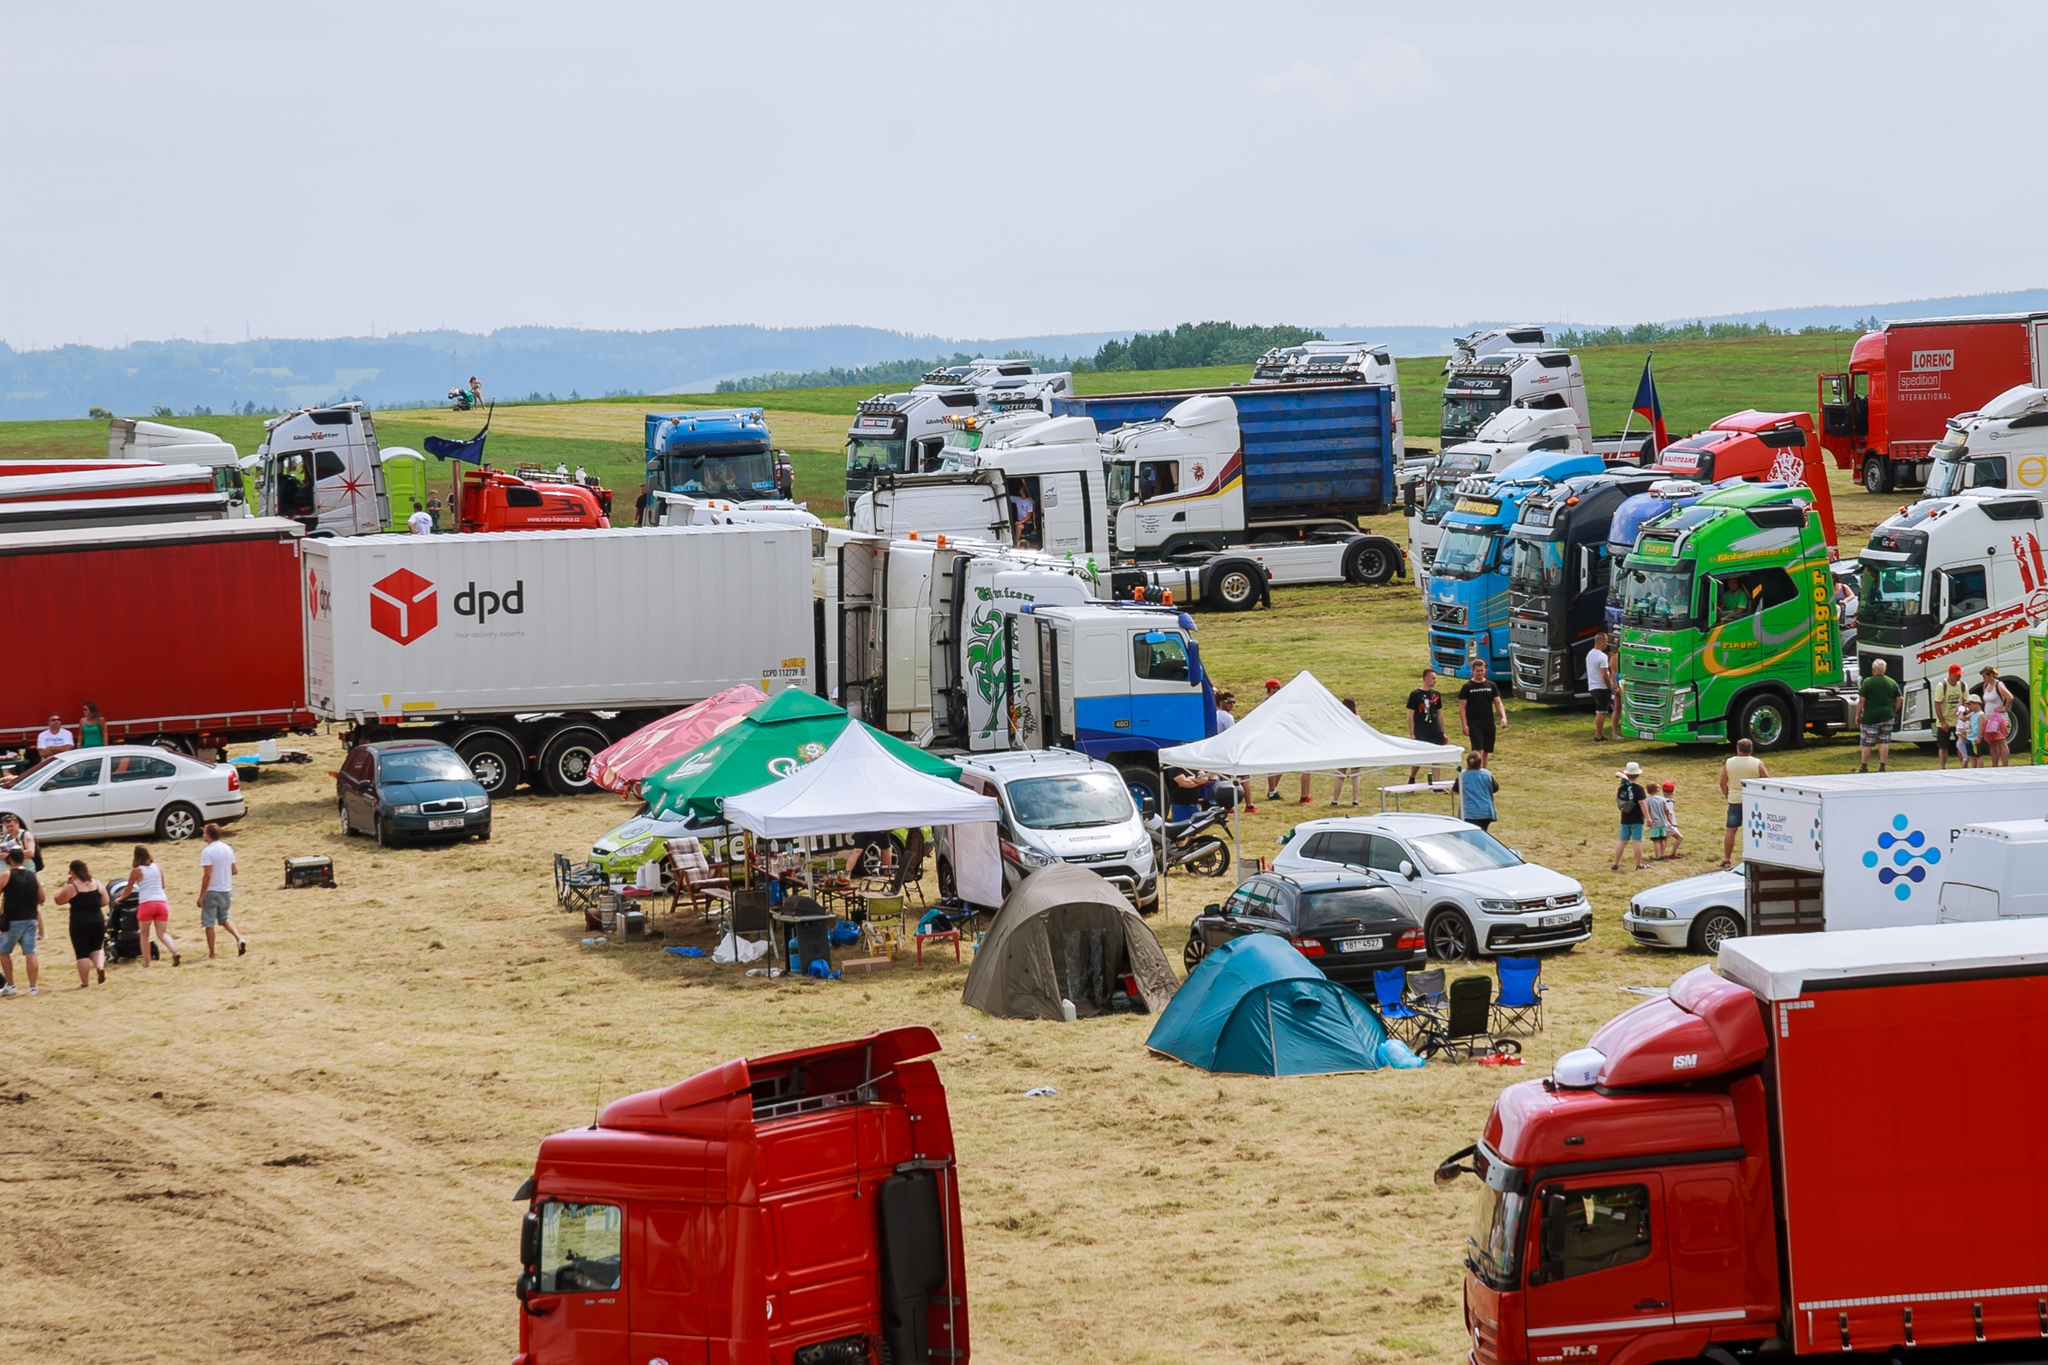What is this photo about'?
 The image captures a vibrant scene of a large gathering of trucks and trailers in an open field. The trucks, varying in colors and sizes, are scattered throughout the field, some bearing logos or company names. Tents and cars are interspersed among the trucks, adding to the bustling atmosphere. The field, covered in lush green grass, contrasts with the overcast sky above. The perspective of the image is from above, providing a bird's eye view of the scene, emphasizing the scale and diversity of the gathering. As for the landmark information "sa_10420", I'm afraid I couldn't find any relevant information about it. It might be helpful to provide more context or check if the information is correct. 